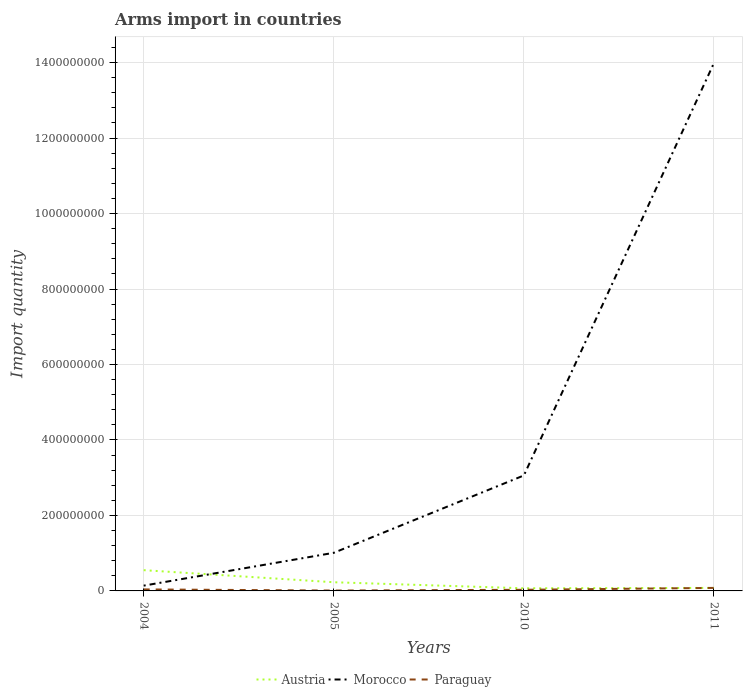How many different coloured lines are there?
Your answer should be compact. 3. Does the line corresponding to Austria intersect with the line corresponding to Morocco?
Provide a short and direct response. Yes. Is the number of lines equal to the number of legend labels?
Your answer should be very brief. Yes. Across all years, what is the maximum total arms import in Morocco?
Provide a succinct answer. 1.40e+07. What is the total total arms import in Paraguay in the graph?
Provide a short and direct response. -4.00e+06. What is the difference between the highest and the second highest total arms import in Morocco?
Your answer should be compact. 1.38e+09. What is the difference between two consecutive major ticks on the Y-axis?
Make the answer very short. 2.00e+08. Are the values on the major ticks of Y-axis written in scientific E-notation?
Ensure brevity in your answer.  No. Does the graph contain any zero values?
Make the answer very short. No. Does the graph contain grids?
Keep it short and to the point. Yes. Where does the legend appear in the graph?
Keep it short and to the point. Bottom center. How many legend labels are there?
Give a very brief answer. 3. What is the title of the graph?
Your answer should be very brief. Arms import in countries. Does "India" appear as one of the legend labels in the graph?
Ensure brevity in your answer.  No. What is the label or title of the Y-axis?
Offer a terse response. Import quantity. What is the Import quantity in Austria in 2004?
Keep it short and to the point. 5.50e+07. What is the Import quantity of Morocco in 2004?
Your answer should be very brief. 1.40e+07. What is the Import quantity in Austria in 2005?
Offer a terse response. 2.30e+07. What is the Import quantity of Morocco in 2005?
Your response must be concise. 1.01e+08. What is the Import quantity of Morocco in 2010?
Offer a terse response. 3.06e+08. What is the Import quantity of Austria in 2011?
Your answer should be compact. 8.00e+06. What is the Import quantity in Morocco in 2011?
Your answer should be very brief. 1.40e+09. What is the Import quantity of Paraguay in 2011?
Offer a very short reply. 8.00e+06. Across all years, what is the maximum Import quantity in Austria?
Your response must be concise. 5.50e+07. Across all years, what is the maximum Import quantity in Morocco?
Your response must be concise. 1.40e+09. Across all years, what is the minimum Import quantity of Austria?
Ensure brevity in your answer.  7.00e+06. Across all years, what is the minimum Import quantity in Morocco?
Your answer should be very brief. 1.40e+07. What is the total Import quantity of Austria in the graph?
Your answer should be compact. 9.30e+07. What is the total Import quantity in Morocco in the graph?
Offer a very short reply. 1.82e+09. What is the total Import quantity of Paraguay in the graph?
Provide a short and direct response. 1.60e+07. What is the difference between the Import quantity of Austria in 2004 and that in 2005?
Your response must be concise. 3.20e+07. What is the difference between the Import quantity in Morocco in 2004 and that in 2005?
Provide a succinct answer. -8.70e+07. What is the difference between the Import quantity of Paraguay in 2004 and that in 2005?
Make the answer very short. 3.00e+06. What is the difference between the Import quantity in Austria in 2004 and that in 2010?
Keep it short and to the point. 4.80e+07. What is the difference between the Import quantity in Morocco in 2004 and that in 2010?
Provide a succinct answer. -2.92e+08. What is the difference between the Import quantity of Paraguay in 2004 and that in 2010?
Offer a terse response. 1.00e+06. What is the difference between the Import quantity of Austria in 2004 and that in 2011?
Your response must be concise. 4.70e+07. What is the difference between the Import quantity of Morocco in 2004 and that in 2011?
Provide a short and direct response. -1.38e+09. What is the difference between the Import quantity of Paraguay in 2004 and that in 2011?
Provide a short and direct response. -4.00e+06. What is the difference between the Import quantity in Austria in 2005 and that in 2010?
Provide a succinct answer. 1.60e+07. What is the difference between the Import quantity in Morocco in 2005 and that in 2010?
Offer a terse response. -2.05e+08. What is the difference between the Import quantity of Austria in 2005 and that in 2011?
Keep it short and to the point. 1.50e+07. What is the difference between the Import quantity in Morocco in 2005 and that in 2011?
Provide a short and direct response. -1.30e+09. What is the difference between the Import quantity of Paraguay in 2005 and that in 2011?
Keep it short and to the point. -7.00e+06. What is the difference between the Import quantity of Austria in 2010 and that in 2011?
Provide a succinct answer. -1.00e+06. What is the difference between the Import quantity of Morocco in 2010 and that in 2011?
Provide a short and direct response. -1.09e+09. What is the difference between the Import quantity of Paraguay in 2010 and that in 2011?
Make the answer very short. -5.00e+06. What is the difference between the Import quantity in Austria in 2004 and the Import quantity in Morocco in 2005?
Your answer should be very brief. -4.60e+07. What is the difference between the Import quantity of Austria in 2004 and the Import quantity of Paraguay in 2005?
Your answer should be compact. 5.40e+07. What is the difference between the Import quantity in Morocco in 2004 and the Import quantity in Paraguay in 2005?
Your answer should be compact. 1.30e+07. What is the difference between the Import quantity in Austria in 2004 and the Import quantity in Morocco in 2010?
Provide a short and direct response. -2.51e+08. What is the difference between the Import quantity in Austria in 2004 and the Import quantity in Paraguay in 2010?
Keep it short and to the point. 5.20e+07. What is the difference between the Import quantity of Morocco in 2004 and the Import quantity of Paraguay in 2010?
Make the answer very short. 1.10e+07. What is the difference between the Import quantity of Austria in 2004 and the Import quantity of Morocco in 2011?
Offer a very short reply. -1.34e+09. What is the difference between the Import quantity of Austria in 2004 and the Import quantity of Paraguay in 2011?
Keep it short and to the point. 4.70e+07. What is the difference between the Import quantity in Morocco in 2004 and the Import quantity in Paraguay in 2011?
Make the answer very short. 6.00e+06. What is the difference between the Import quantity in Austria in 2005 and the Import quantity in Morocco in 2010?
Provide a succinct answer. -2.83e+08. What is the difference between the Import quantity in Morocco in 2005 and the Import quantity in Paraguay in 2010?
Your answer should be compact. 9.80e+07. What is the difference between the Import quantity of Austria in 2005 and the Import quantity of Morocco in 2011?
Your answer should be compact. -1.38e+09. What is the difference between the Import quantity in Austria in 2005 and the Import quantity in Paraguay in 2011?
Make the answer very short. 1.50e+07. What is the difference between the Import quantity of Morocco in 2005 and the Import quantity of Paraguay in 2011?
Offer a very short reply. 9.30e+07. What is the difference between the Import quantity in Austria in 2010 and the Import quantity in Morocco in 2011?
Offer a very short reply. -1.39e+09. What is the difference between the Import quantity of Austria in 2010 and the Import quantity of Paraguay in 2011?
Give a very brief answer. -1.00e+06. What is the difference between the Import quantity of Morocco in 2010 and the Import quantity of Paraguay in 2011?
Offer a very short reply. 2.98e+08. What is the average Import quantity of Austria per year?
Keep it short and to the point. 2.32e+07. What is the average Import quantity of Morocco per year?
Your answer should be compact. 4.55e+08. What is the average Import quantity in Paraguay per year?
Provide a succinct answer. 4.00e+06. In the year 2004, what is the difference between the Import quantity in Austria and Import quantity in Morocco?
Keep it short and to the point. 4.10e+07. In the year 2004, what is the difference between the Import quantity of Austria and Import quantity of Paraguay?
Your answer should be very brief. 5.10e+07. In the year 2004, what is the difference between the Import quantity of Morocco and Import quantity of Paraguay?
Ensure brevity in your answer.  1.00e+07. In the year 2005, what is the difference between the Import quantity of Austria and Import quantity of Morocco?
Your answer should be compact. -7.80e+07. In the year 2005, what is the difference between the Import quantity in Austria and Import quantity in Paraguay?
Ensure brevity in your answer.  2.20e+07. In the year 2005, what is the difference between the Import quantity in Morocco and Import quantity in Paraguay?
Make the answer very short. 1.00e+08. In the year 2010, what is the difference between the Import quantity in Austria and Import quantity in Morocco?
Your response must be concise. -2.99e+08. In the year 2010, what is the difference between the Import quantity in Austria and Import quantity in Paraguay?
Your response must be concise. 4.00e+06. In the year 2010, what is the difference between the Import quantity in Morocco and Import quantity in Paraguay?
Make the answer very short. 3.03e+08. In the year 2011, what is the difference between the Import quantity in Austria and Import quantity in Morocco?
Your answer should be very brief. -1.39e+09. In the year 2011, what is the difference between the Import quantity in Morocco and Import quantity in Paraguay?
Provide a short and direct response. 1.39e+09. What is the ratio of the Import quantity in Austria in 2004 to that in 2005?
Provide a short and direct response. 2.39. What is the ratio of the Import quantity of Morocco in 2004 to that in 2005?
Make the answer very short. 0.14. What is the ratio of the Import quantity of Paraguay in 2004 to that in 2005?
Your answer should be compact. 4. What is the ratio of the Import quantity of Austria in 2004 to that in 2010?
Provide a succinct answer. 7.86. What is the ratio of the Import quantity of Morocco in 2004 to that in 2010?
Provide a short and direct response. 0.05. What is the ratio of the Import quantity of Austria in 2004 to that in 2011?
Your answer should be compact. 6.88. What is the ratio of the Import quantity of Paraguay in 2004 to that in 2011?
Give a very brief answer. 0.5. What is the ratio of the Import quantity in Austria in 2005 to that in 2010?
Ensure brevity in your answer.  3.29. What is the ratio of the Import quantity of Morocco in 2005 to that in 2010?
Your answer should be compact. 0.33. What is the ratio of the Import quantity of Paraguay in 2005 to that in 2010?
Give a very brief answer. 0.33. What is the ratio of the Import quantity in Austria in 2005 to that in 2011?
Your response must be concise. 2.88. What is the ratio of the Import quantity of Morocco in 2005 to that in 2011?
Keep it short and to the point. 0.07. What is the ratio of the Import quantity in Austria in 2010 to that in 2011?
Offer a terse response. 0.88. What is the ratio of the Import quantity in Morocco in 2010 to that in 2011?
Ensure brevity in your answer.  0.22. What is the ratio of the Import quantity in Paraguay in 2010 to that in 2011?
Your answer should be compact. 0.38. What is the difference between the highest and the second highest Import quantity of Austria?
Keep it short and to the point. 3.20e+07. What is the difference between the highest and the second highest Import quantity of Morocco?
Your response must be concise. 1.09e+09. What is the difference between the highest and the second highest Import quantity of Paraguay?
Offer a very short reply. 4.00e+06. What is the difference between the highest and the lowest Import quantity in Austria?
Ensure brevity in your answer.  4.80e+07. What is the difference between the highest and the lowest Import quantity of Morocco?
Ensure brevity in your answer.  1.38e+09. What is the difference between the highest and the lowest Import quantity in Paraguay?
Give a very brief answer. 7.00e+06. 